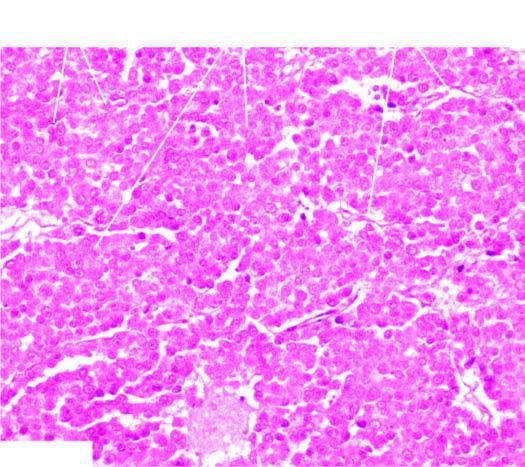s the sectioned surface identical to that of seminoma of the testis?
Answer the question using a single word or phrase. No 